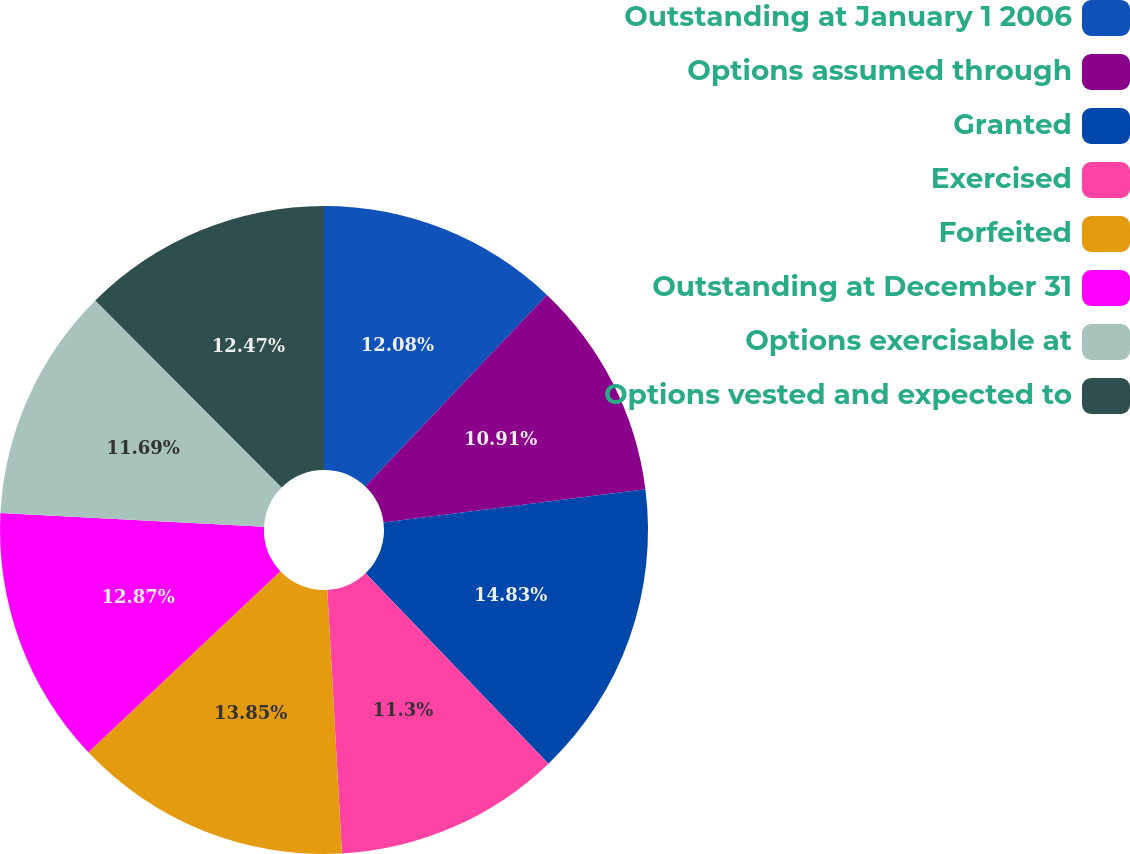Convert chart to OTSL. <chart><loc_0><loc_0><loc_500><loc_500><pie_chart><fcel>Outstanding at January 1 2006<fcel>Options assumed through<fcel>Granted<fcel>Exercised<fcel>Forfeited<fcel>Outstanding at December 31<fcel>Options exercisable at<fcel>Options vested and expected to<nl><fcel>12.08%<fcel>10.91%<fcel>14.82%<fcel>11.3%<fcel>13.84%<fcel>12.87%<fcel>11.69%<fcel>12.47%<nl></chart> 